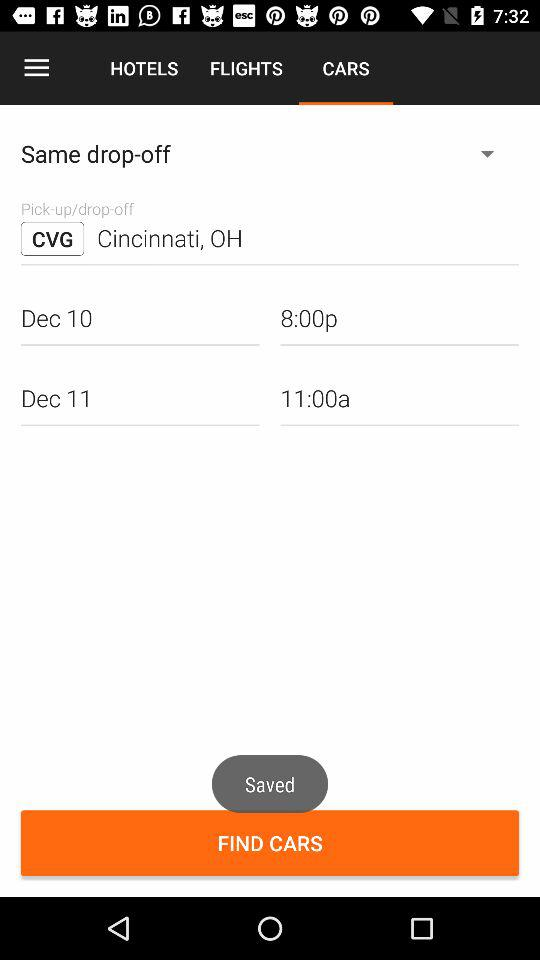What is the drop-off location? The drop-off location is Cincinnati, OH. 